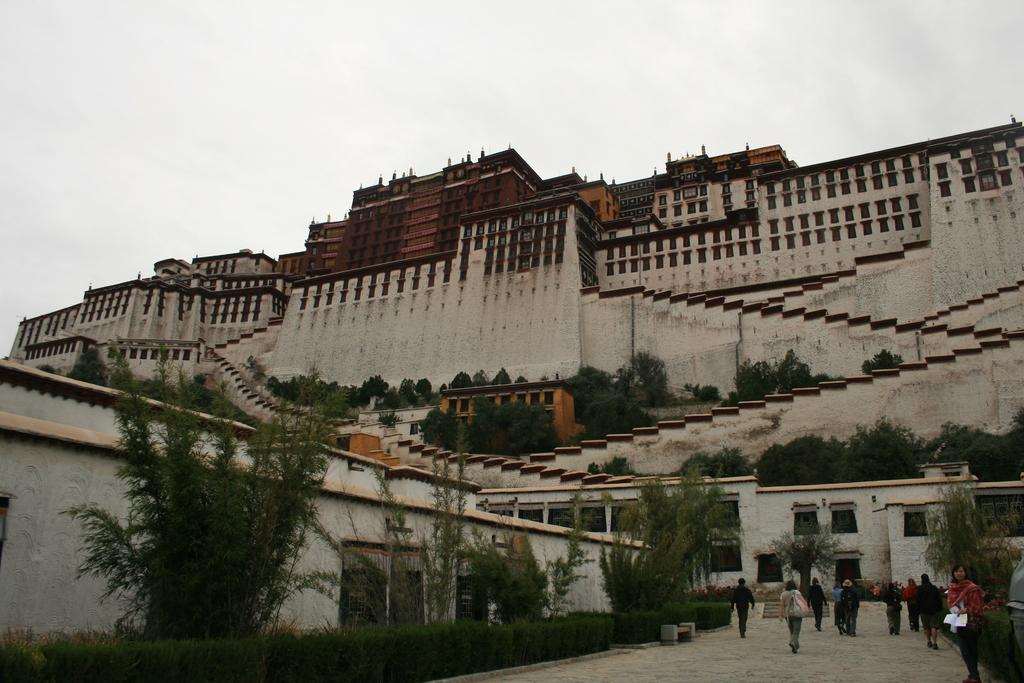What type of structures can be seen in the image? There are buildings in the image. What architectural feature is present in the image? There are stairs in the image. What type of vegetation is visible in the image? There are trees and bushes in the image. Who or what is located at the bottom of the image? There are people at the bottom of the image. What is visible at the top of the image? The sky is visible at the top of the image. What type of prose can be heard being read by the people at the bottom of the image? There is no indication in the image that any prose is being read, so it cannot be determined from the picture. What type of vessel is being used by the people at the bottom of the image? There is no vessel present in the image; the people are standing on the ground. 